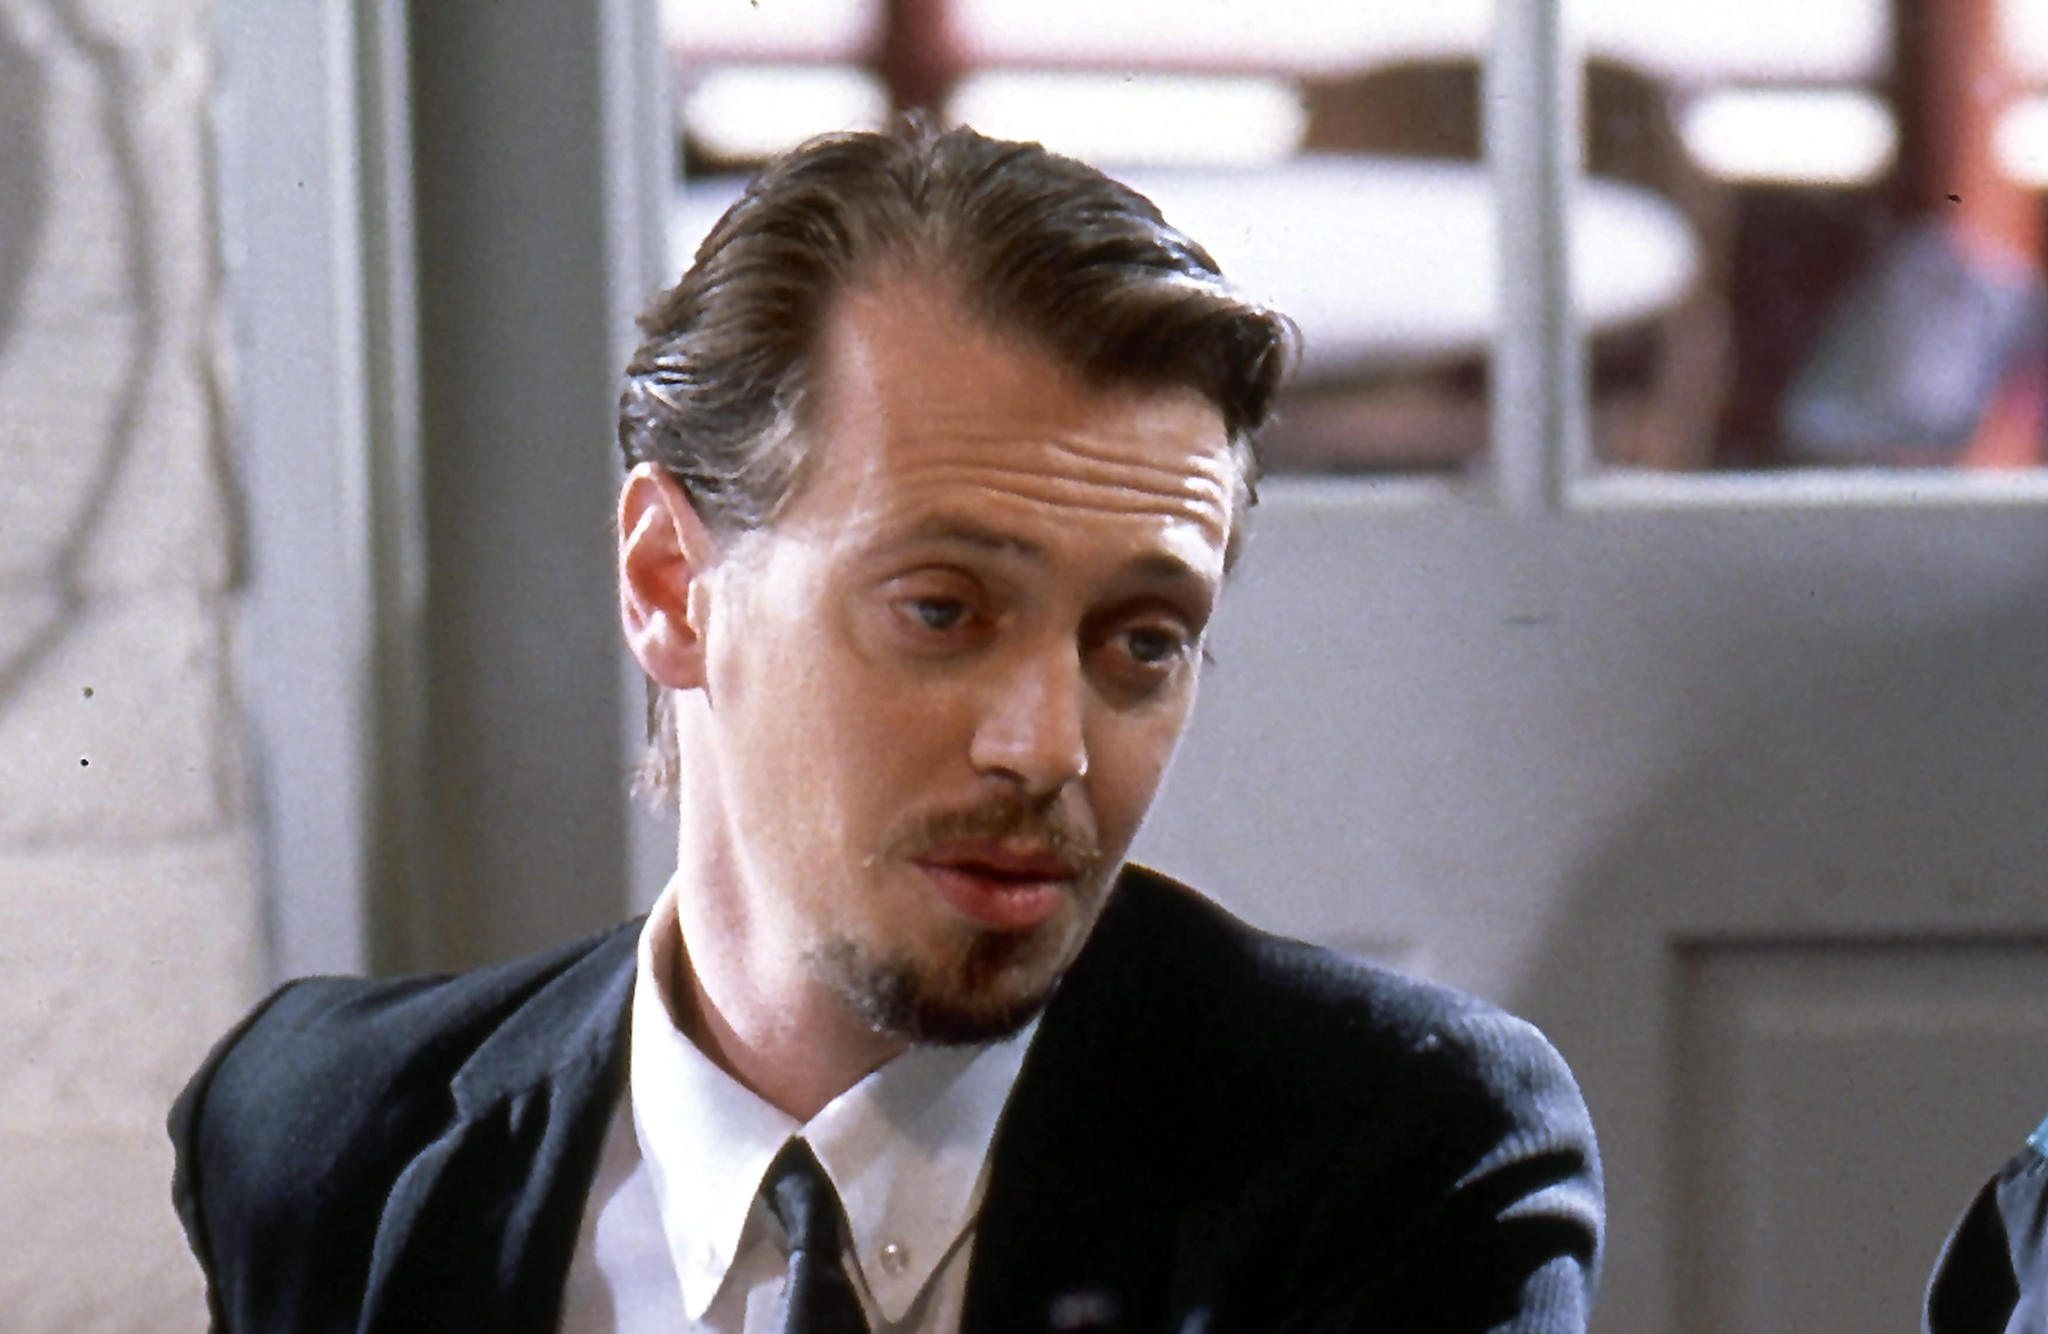What do you see happening in this image? In this image, we see the renowned actor Steve Buscemi, known for his role as Mr. Pink in the 1992 film Reservoir Dogs. He is seated, seemingly lost in deep reflection, with an intense and thoughtful gaze directed outside the frame. His formal attire, including a black suit and tie, brings a sharp contrast to his light complexion and the somewhat blurred background, which suggests a restaurant or café setting. His distinctive facial features, marked by a mustache and goatee, enhance the depth and complexity of his character, adding to the contemplative mood of the scene. 